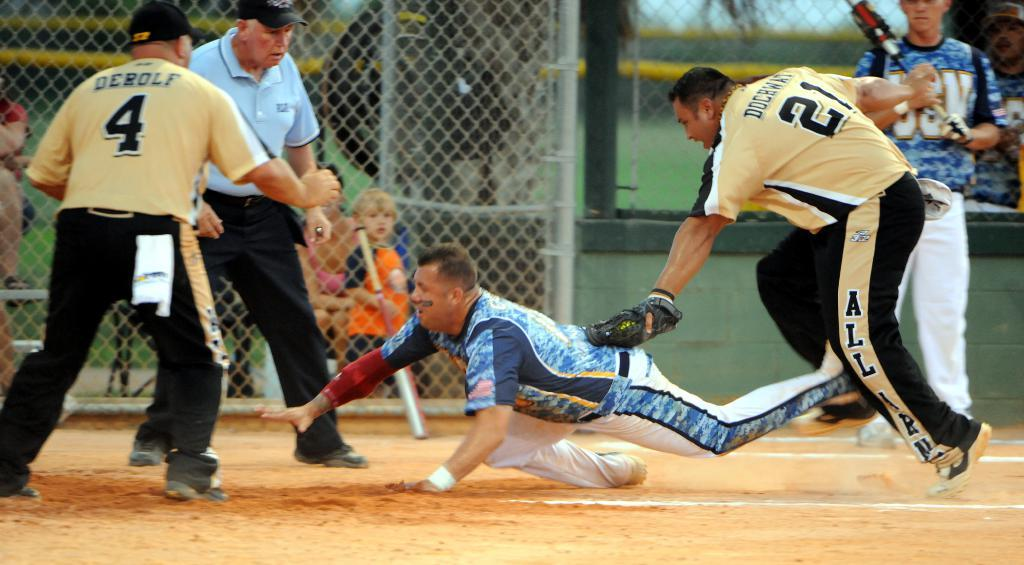Provide a one-sentence caption for the provided image. Number 21 is the on the uniform of the player tagging at home plate. 